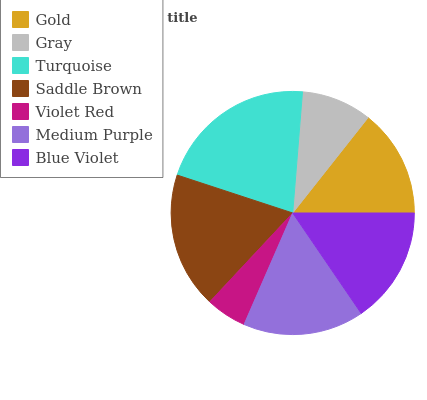Is Violet Red the minimum?
Answer yes or no. Yes. Is Turquoise the maximum?
Answer yes or no. Yes. Is Gray the minimum?
Answer yes or no. No. Is Gray the maximum?
Answer yes or no. No. Is Gold greater than Gray?
Answer yes or no. Yes. Is Gray less than Gold?
Answer yes or no. Yes. Is Gray greater than Gold?
Answer yes or no. No. Is Gold less than Gray?
Answer yes or no. No. Is Blue Violet the high median?
Answer yes or no. Yes. Is Blue Violet the low median?
Answer yes or no. Yes. Is Turquoise the high median?
Answer yes or no. No. Is Medium Purple the low median?
Answer yes or no. No. 